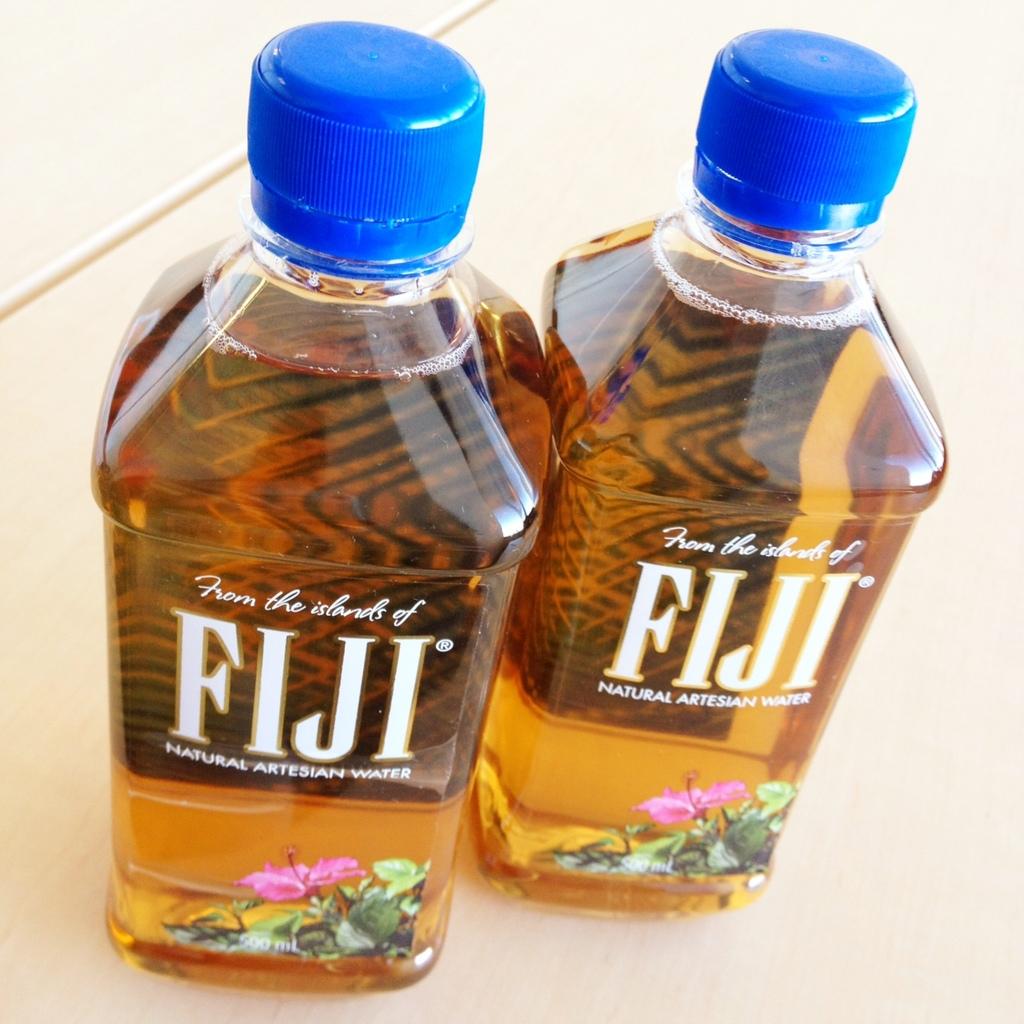Which island does the water come from?
Make the answer very short. Fiji. What kind of water is this?
Offer a terse response. Fiji. 